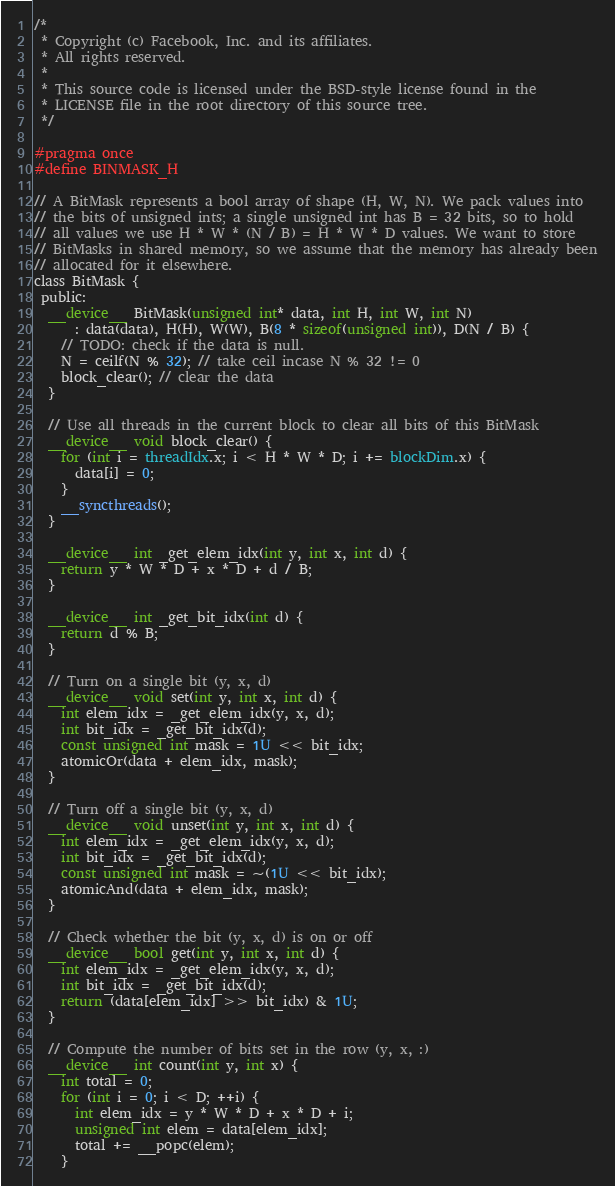<code> <loc_0><loc_0><loc_500><loc_500><_Cuda_>/*
 * Copyright (c) Facebook, Inc. and its affiliates.
 * All rights reserved.
 *
 * This source code is licensed under the BSD-style license found in the
 * LICENSE file in the root directory of this source tree.
 */

#pragma once
#define BINMASK_H

// A BitMask represents a bool array of shape (H, W, N). We pack values into
// the bits of unsigned ints; a single unsigned int has B = 32 bits, so to hold
// all values we use H * W * (N / B) = H * W * D values. We want to store
// BitMasks in shared memory, so we assume that the memory has already been
// allocated for it elsewhere.
class BitMask {
 public:
  __device__ BitMask(unsigned int* data, int H, int W, int N)
      : data(data), H(H), W(W), B(8 * sizeof(unsigned int)), D(N / B) {
    // TODO: check if the data is null.
    N = ceilf(N % 32); // take ceil incase N % 32 != 0
    block_clear(); // clear the data
  }

  // Use all threads in the current block to clear all bits of this BitMask
  __device__ void block_clear() {
    for (int i = threadIdx.x; i < H * W * D; i += blockDim.x) {
      data[i] = 0;
    }
    __syncthreads();
  }

  __device__ int _get_elem_idx(int y, int x, int d) {
    return y * W * D + x * D + d / B;
  }

  __device__ int _get_bit_idx(int d) {
    return d % B;
  }

  // Turn on a single bit (y, x, d)
  __device__ void set(int y, int x, int d) {
    int elem_idx = _get_elem_idx(y, x, d);
    int bit_idx = _get_bit_idx(d);
    const unsigned int mask = 1U << bit_idx;
    atomicOr(data + elem_idx, mask);
  }

  // Turn off a single bit (y, x, d)
  __device__ void unset(int y, int x, int d) {
    int elem_idx = _get_elem_idx(y, x, d);
    int bit_idx = _get_bit_idx(d);
    const unsigned int mask = ~(1U << bit_idx);
    atomicAnd(data + elem_idx, mask);
  }

  // Check whether the bit (y, x, d) is on or off
  __device__ bool get(int y, int x, int d) {
    int elem_idx = _get_elem_idx(y, x, d);
    int bit_idx = _get_bit_idx(d);
    return (data[elem_idx] >> bit_idx) & 1U;
  }

  // Compute the number of bits set in the row (y, x, :)
  __device__ int count(int y, int x) {
    int total = 0;
    for (int i = 0; i < D; ++i) {
      int elem_idx = y * W * D + x * D + i;
      unsigned int elem = data[elem_idx];
      total += __popc(elem);
    }</code> 